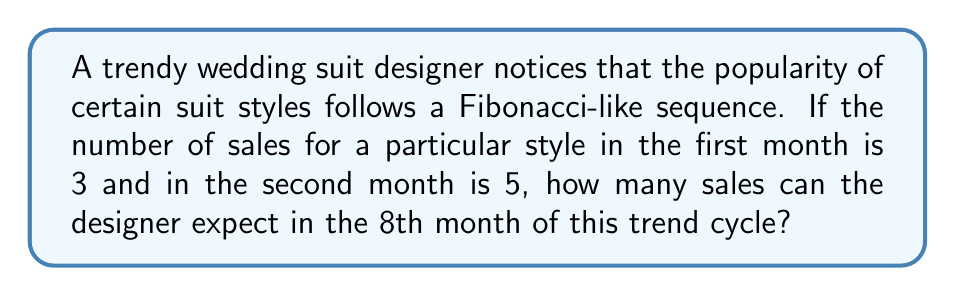Solve this math problem. Let's approach this step-by-step:

1) The Fibonacci sequence typically starts with 0 and 1, but in this case, we're given a modified sequence starting with 3 and 5.

2) Let's write out the sequence for the first few months:
   Month 1: 3
   Month 2: 5
   Month 3: 3 + 5 = 8
   Month 4: 5 + 8 = 13
   Month 5: 8 + 13 = 21
   Month 6: 13 + 21 = 34
   Month 7: 21 + 34 = 55
   Month 8: 34 + 55 = 89

3) We can express this mathematically as:

   $$F_n = F_{n-1} + F_{n-2}$$

   Where $F_n$ is the number of sales in the nth month, and $F_1 = 3$, $F_2 = 5$.

4) To find the 8th term, we calculated:

   $$F_8 = F_7 + F_6 = 55 + 34 = 89$$

Therefore, the designer can expect 89 sales in the 8th month of this trend cycle.
Answer: 89 